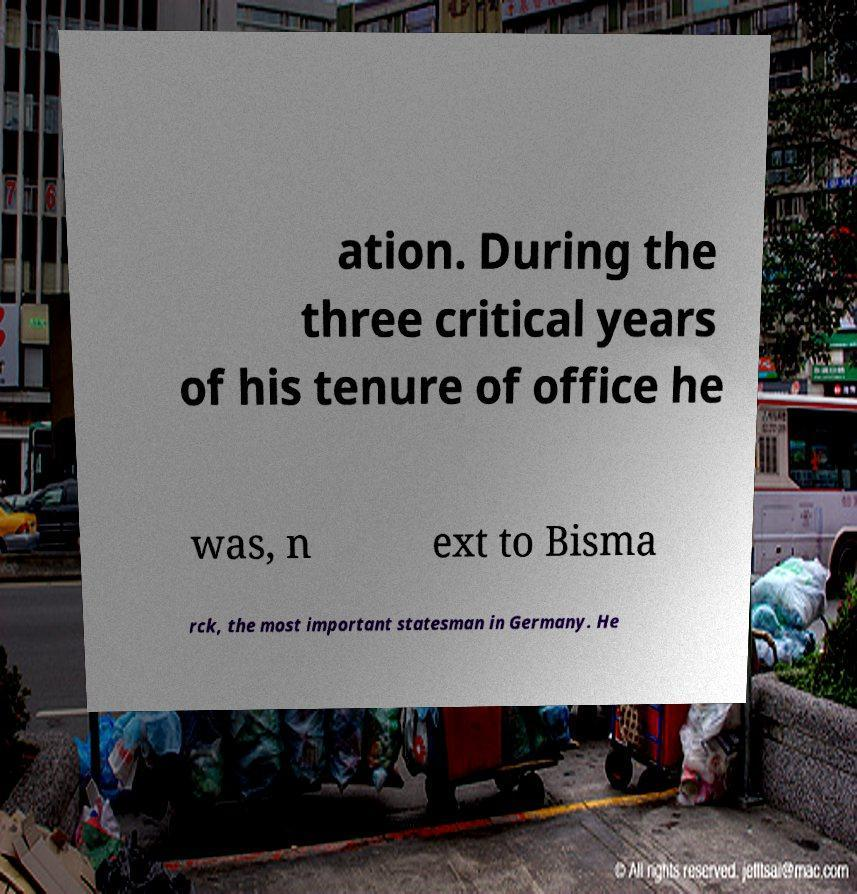Can you accurately transcribe the text from the provided image for me? ation. During the three critical years of his tenure of office he was, n ext to Bisma rck, the most important statesman in Germany. He 